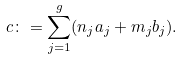Convert formula to latex. <formula><loc_0><loc_0><loc_500><loc_500>c \colon = \sum _ { j = 1 } ^ { g } ( n _ { j } a _ { j } + m _ { j } b _ { j } ) .</formula> 